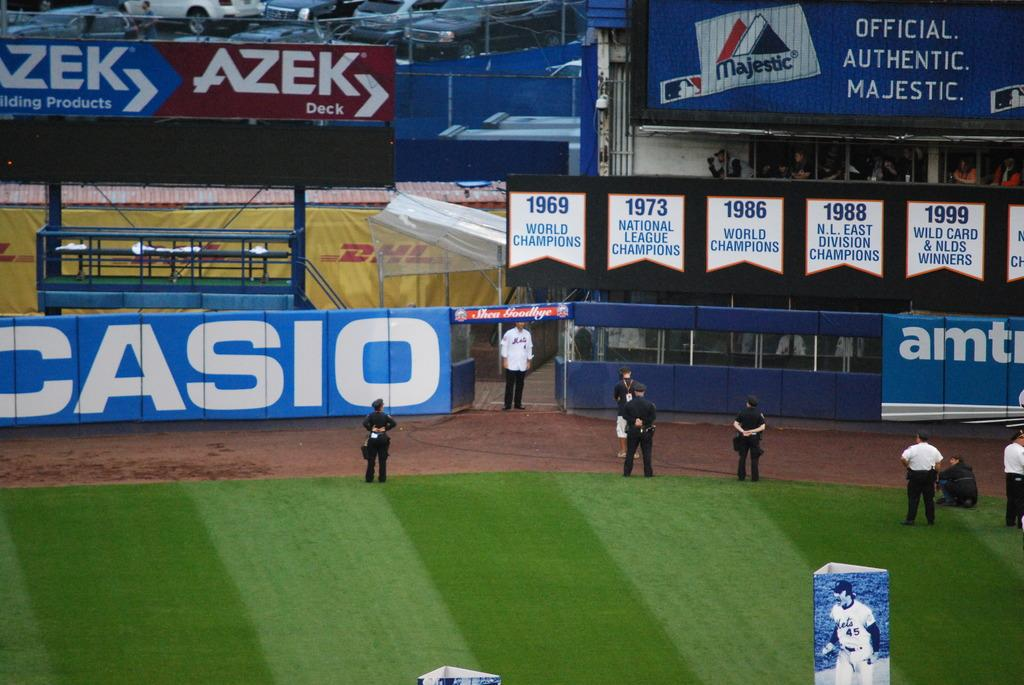<image>
Write a terse but informative summary of the picture. Baseball game security standing in front of a banner with Casio in white. 